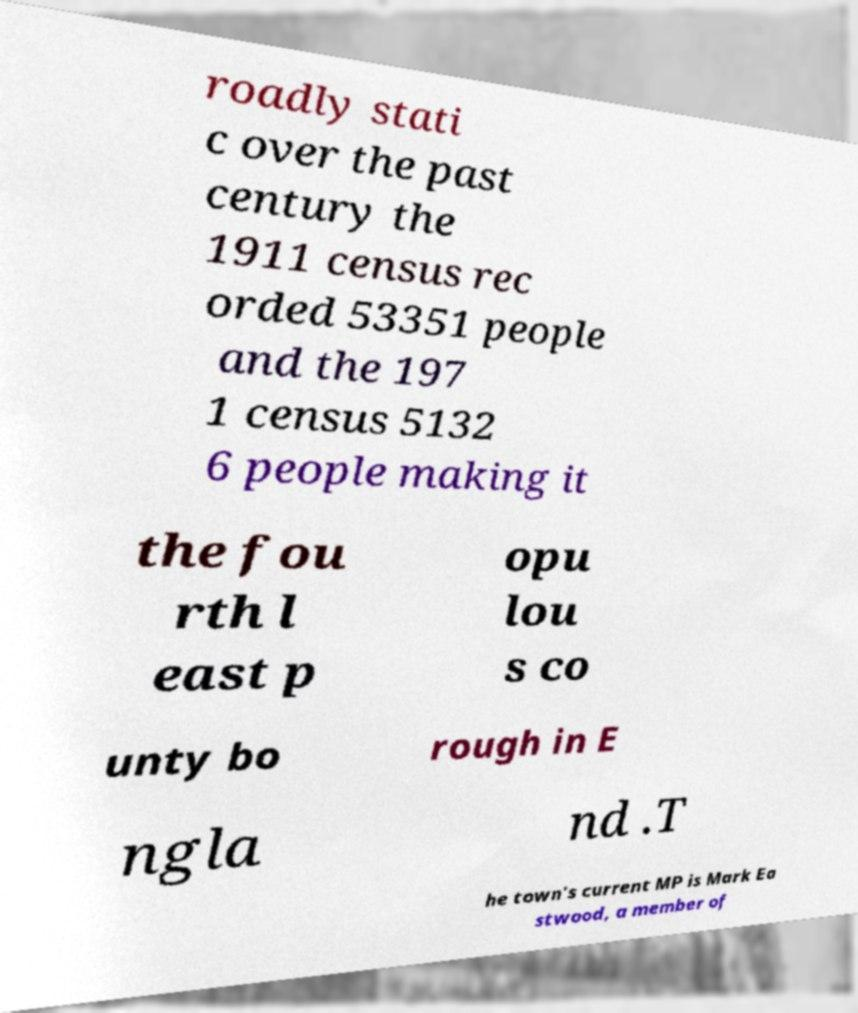What messages or text are displayed in this image? I need them in a readable, typed format. roadly stati c over the past century the 1911 census rec orded 53351 people and the 197 1 census 5132 6 people making it the fou rth l east p opu lou s co unty bo rough in E ngla nd .T he town's current MP is Mark Ea stwood, a member of 